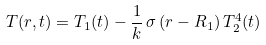Convert formula to latex. <formula><loc_0><loc_0><loc_500><loc_500>T ( r , t ) = T _ { 1 } ( t ) - \frac { 1 } { k } \, \sigma \, ( r - R _ { 1 } ) \, T _ { 2 } ^ { 4 } ( t )</formula> 